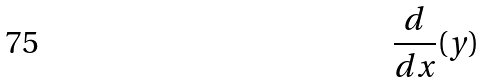<formula> <loc_0><loc_0><loc_500><loc_500>\frac { d } { d x } ( y )</formula> 